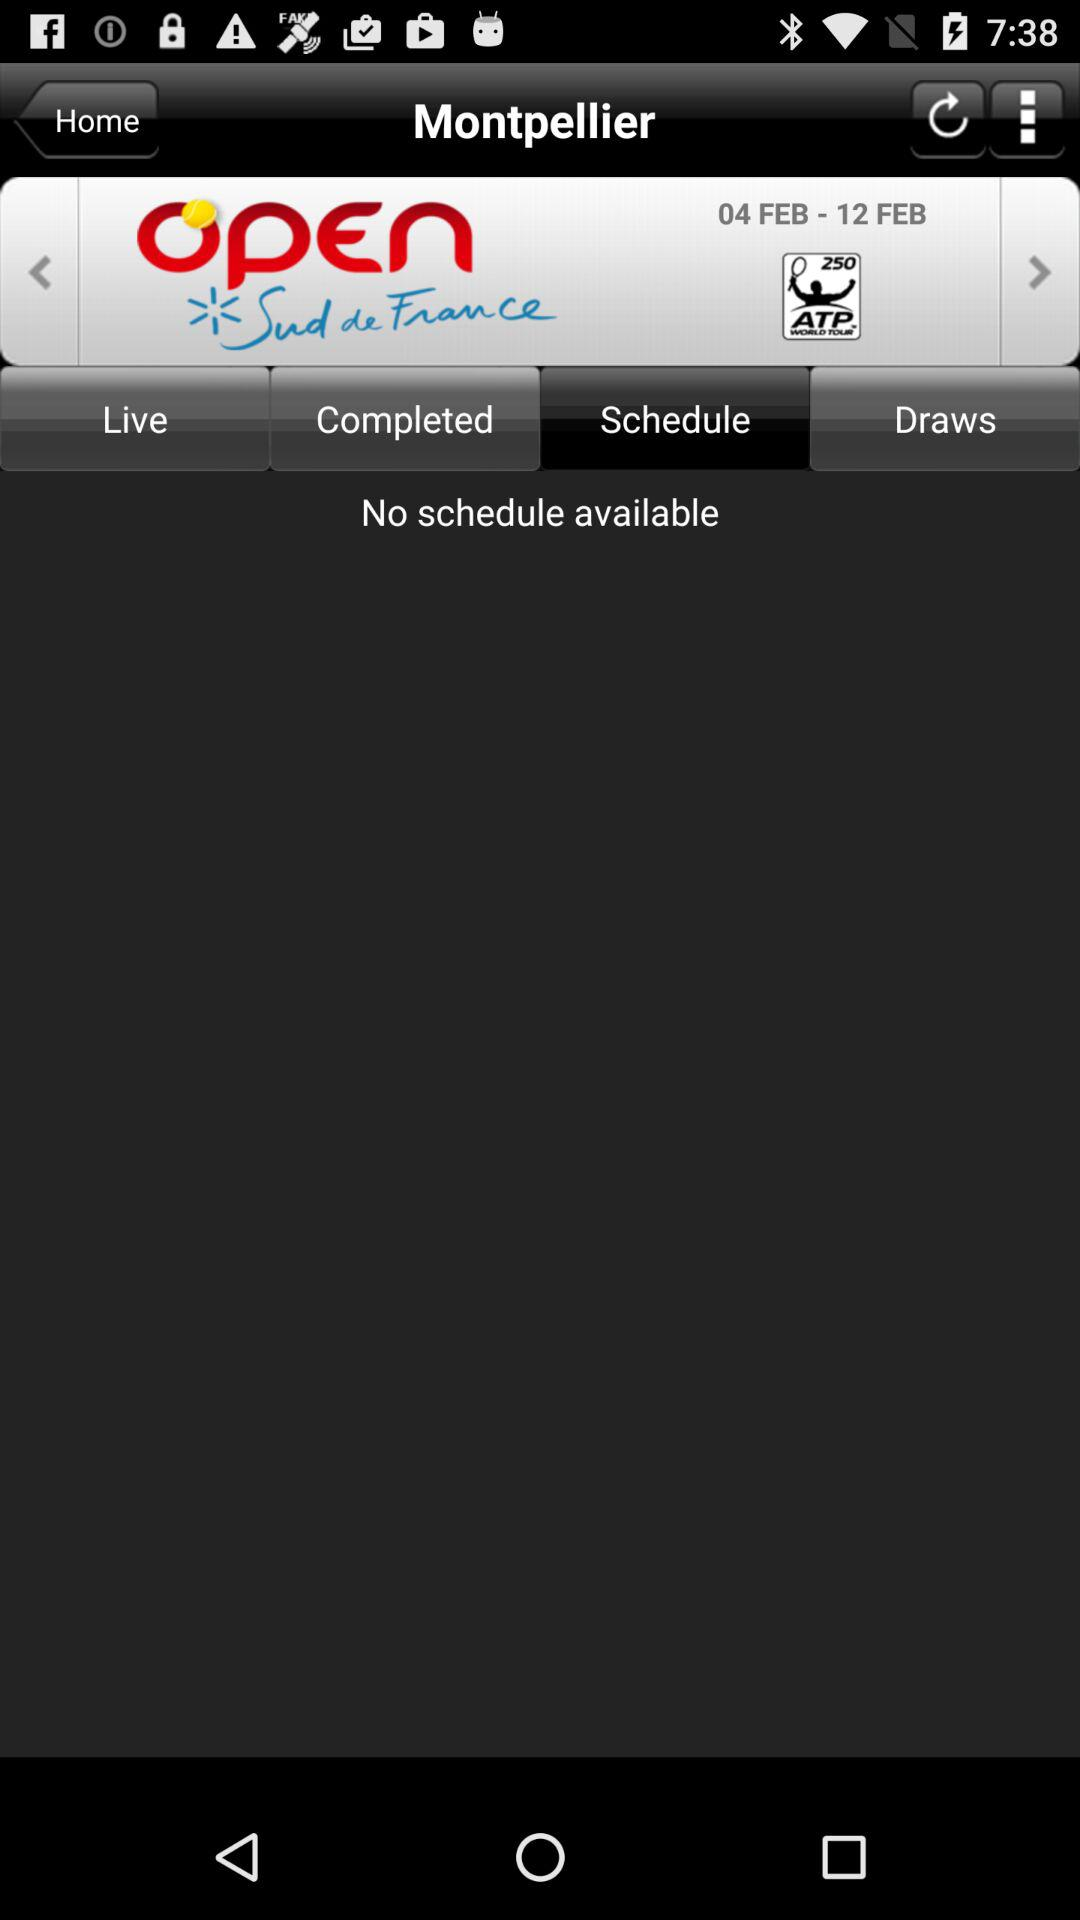What are the mentioned dates? The mentioned dates are from February 4 to February 12. 